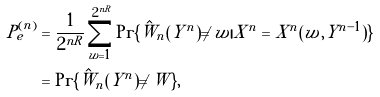<formula> <loc_0><loc_0><loc_500><loc_500>P _ { e } ^ { ( n ) } & = \frac { 1 } { 2 ^ { n R } } \sum _ { w = 1 } ^ { 2 ^ { n R } } \Pr \{ \hat { W } _ { n } ( Y ^ { n } ) \ne w | X ^ { n } = X ^ { n } ( w , Y ^ { n - 1 } ) \} \\ & = \Pr \{ \hat { W } _ { n } ( Y ^ { n } ) \ne W \} ,</formula> 